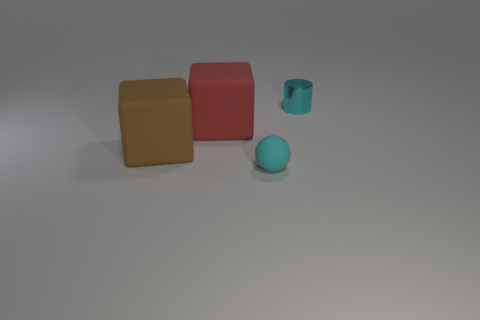Add 3 large green shiny objects. How many objects exist? 7 Subtract all red blocks. How many blocks are left? 1 Subtract 0 cyan cubes. How many objects are left? 4 Subtract all gray balls. Subtract all purple cylinders. How many balls are left? 1 Subtract all gray cylinders. How many brown cubes are left? 1 Subtract all small cyan matte balls. Subtract all cyan things. How many objects are left? 1 Add 3 matte spheres. How many matte spheres are left? 4 Add 3 tiny cylinders. How many tiny cylinders exist? 4 